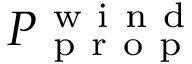<formula> <loc_0><loc_0><loc_500><loc_500>P _ { p r o p } ^ { w i n d }</formula> 